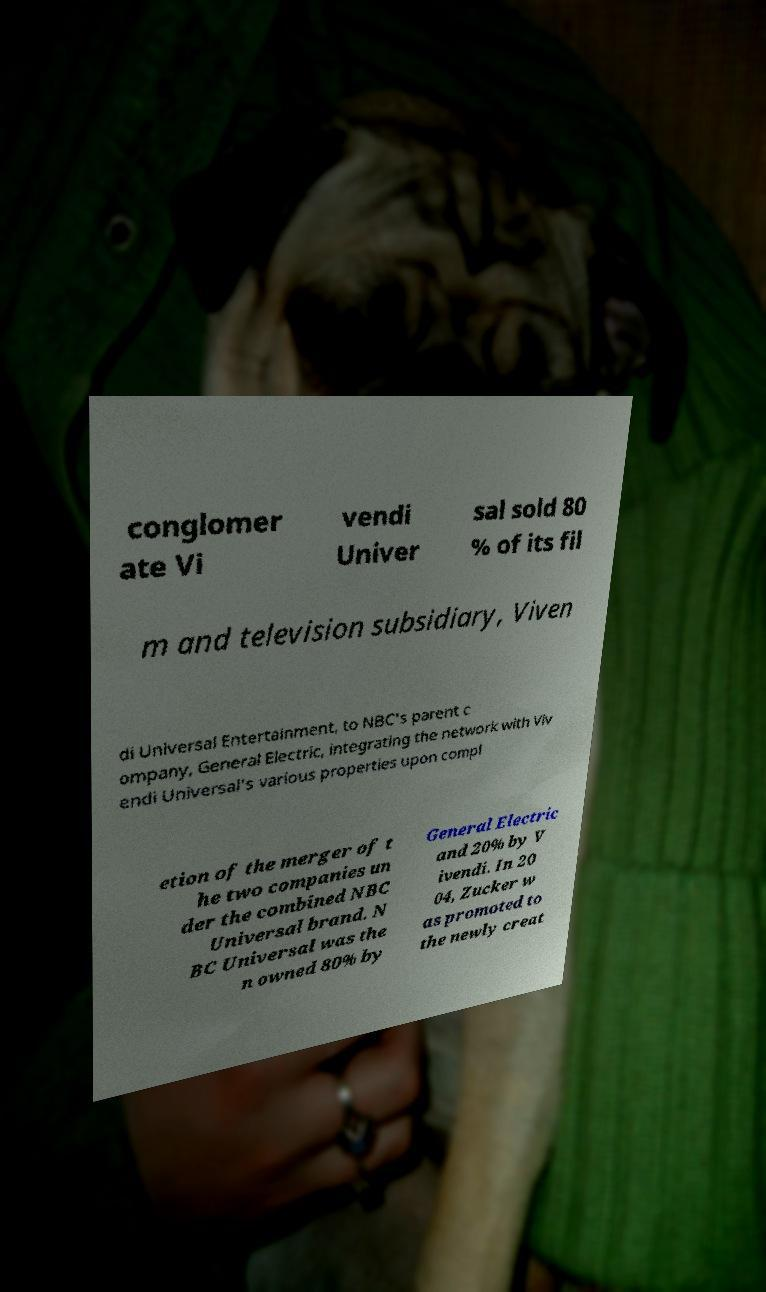I need the written content from this picture converted into text. Can you do that? conglomer ate Vi vendi Univer sal sold 80 % of its fil m and television subsidiary, Viven di Universal Entertainment, to NBC's parent c ompany, General Electric, integrating the network with Viv endi Universal's various properties upon compl etion of the merger of t he two companies un der the combined NBC Universal brand. N BC Universal was the n owned 80% by General Electric and 20% by V ivendi. In 20 04, Zucker w as promoted to the newly creat 